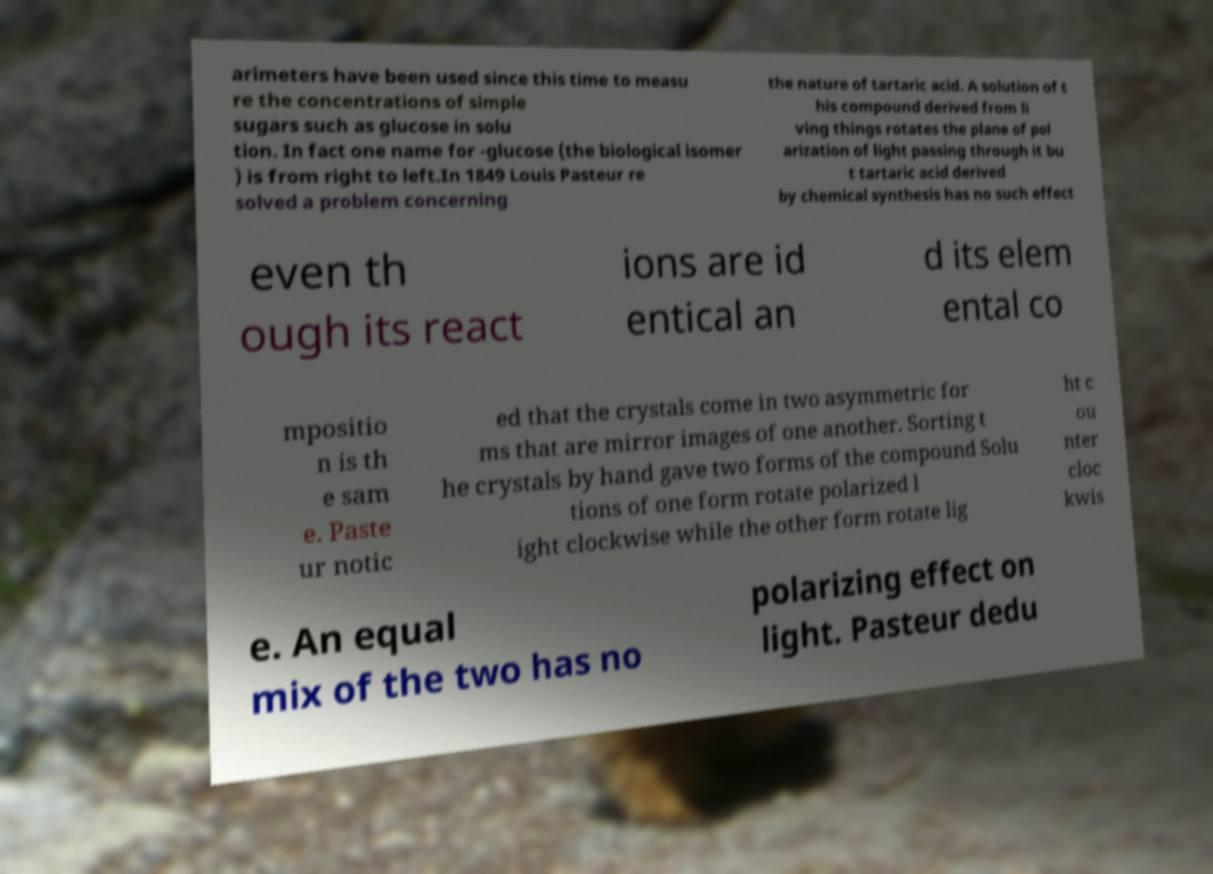Please identify and transcribe the text found in this image. arimeters have been used since this time to measu re the concentrations of simple sugars such as glucose in solu tion. In fact one name for -glucose (the biological isomer ) is from right to left.In 1849 Louis Pasteur re solved a problem concerning the nature of tartaric acid. A solution of t his compound derived from li ving things rotates the plane of pol arization of light passing through it bu t tartaric acid derived by chemical synthesis has no such effect even th ough its react ions are id entical an d its elem ental co mpositio n is th e sam e. Paste ur notic ed that the crystals come in two asymmetric for ms that are mirror images of one another. Sorting t he crystals by hand gave two forms of the compound Solu tions of one form rotate polarized l ight clockwise while the other form rotate lig ht c ou nter cloc kwis e. An equal mix of the two has no polarizing effect on light. Pasteur dedu 